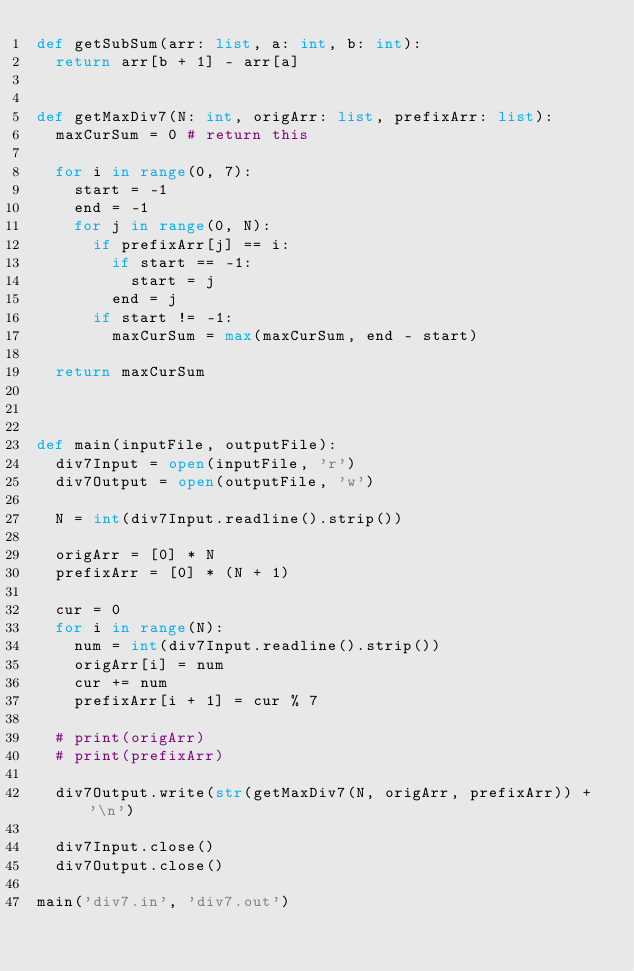Convert code to text. <code><loc_0><loc_0><loc_500><loc_500><_Python_>def getSubSum(arr: list, a: int, b: int):
  return arr[b + 1] - arr[a]


def getMaxDiv7(N: int, origArr: list, prefixArr: list):
  maxCurSum = 0 # return this
  
  for i in range(0, 7):
    start = -1
    end = -1
    for j in range(0, N):
      if prefixArr[j] == i:
        if start == -1:
          start = j
        end = j
      if start != -1:
        maxCurSum = max(maxCurSum, end - start)

  return maxCurSum      
      


def main(inputFile, outputFile):
  div7Input = open(inputFile, 'r')
  div7Output = open(outputFile, 'w')
  
  N = int(div7Input.readline().strip())
  
  origArr = [0] * N
  prefixArr = [0] * (N + 1)
  
  cur = 0  
  for i in range(N):
    num = int(div7Input.readline().strip())
    origArr[i] = num
    cur += num
    prefixArr[i + 1] = cur % 7
  
  # print(origArr)
  # print(prefixArr)

  div7Output.write(str(getMaxDiv7(N, origArr, prefixArr)) + '\n')
  
  div7Input.close()
  div7Output.close()

main('div7.in', 'div7.out')
</code> 